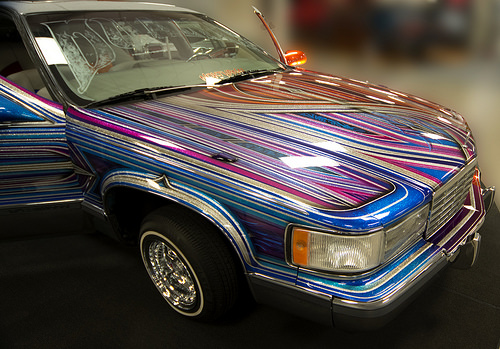<image>
Is the tire to the right of the windscreen? No. The tire is not to the right of the windscreen. The horizontal positioning shows a different relationship. 